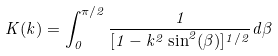<formula> <loc_0><loc_0><loc_500><loc_500>K ( k ) = \int _ { 0 } ^ { \pi / 2 } \frac { 1 } { [ 1 - k ^ { 2 } \sin ^ { 2 } ( \beta ) ] ^ { 1 / 2 } } d \beta</formula> 